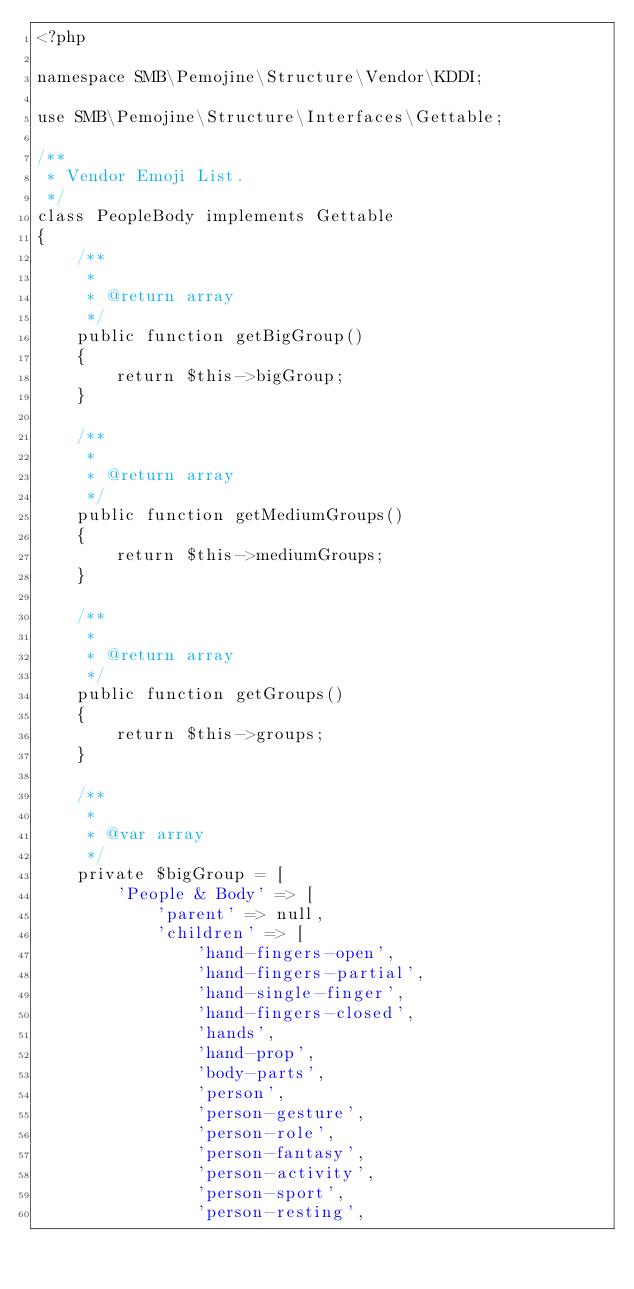Convert code to text. <code><loc_0><loc_0><loc_500><loc_500><_PHP_><?phpnamespace SMB\Pemojine\Structure\Vendor\KDDI;

use SMB\Pemojine\Structure\Interfaces\Gettable;

/**
 * Vendor Emoji List.
 */
class PeopleBody implements Gettable
{
    /**
     * 
     * @return array
     */
    public function getBigGroup()
    {
        return $this->bigGroup;
    }

    /**
     * 
     * @return array
     */
    public function getMediumGroups()
    {
        return $this->mediumGroups;
    }

    /**
     * 
     * @return array
     */
    public function getGroups()
    {
        return $this->groups;
    }

    /**
     * 
     * @var array
     */
    private $bigGroup = [
        'People & Body' => [
            'parent' => null,
            'children' => [
                'hand-fingers-open',
                'hand-fingers-partial',
                'hand-single-finger',
                'hand-fingers-closed',
                'hands',
                'hand-prop',
                'body-parts',
                'person',
                'person-gesture',
                'person-role',
                'person-fantasy',
                'person-activity',
                'person-sport',
                'person-resting',</code> 